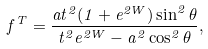Convert formula to latex. <formula><loc_0><loc_0><loc_500><loc_500>f ^ { T } = \frac { a t ^ { 2 } ( 1 + e ^ { 2 W } ) \sin ^ { 2 } \theta } { t ^ { 2 } e ^ { 2 W } - a ^ { 2 } \cos ^ { 2 } \theta } ,</formula> 